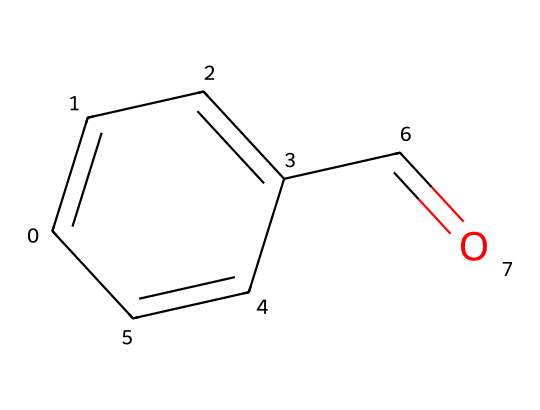What is the molecular formula of benzaldehyde? The molecular formula can be derived from the SMILES representation. In the structure, we have 7 carbon (C) atoms, 6 hydrogen (H) atoms, and 1 oxygen (O) atom, which gives the formula C7H6O.
Answer: C7H6O How many rings are present in benzaldehyde? The SMILES representation shows a cyclic structure with a single six-membered aromatic ring. There are no other rings indicated in the structure.
Answer: 1 What functional group is present in benzaldehyde? The functional group can be identified by looking at the carbonyl (C=O) present in the structure. As it is attached to an aromatic ring, it indicates the presence of an aldehyde.
Answer: aldehyde What is the total number of double bonds in benzaldehyde? By analyzing the SMILES, there are 2 double bonds visible: one in the carbonyl group (C=O) and another in the aromatic ring. Thus, the total number is 2.
Answer: 2 How many hydrogen atoms are adjacent to the carbonyl carbon in benzaldehyde? The carbon atom of the carbonyl group (C=O) is attached to one hydrogen atom in the structure, which makes it an aldehyde. Therefore, the answer is 1.
Answer: 1 What hybridization do the carbon atoms in the carbonyl group exhibit? The carbon atom in the carbonyl group (C=O) has a double bond with oxygen, leading to sp2 hybridization. This is typical for the carbonyl carbon in aldehydes and is evident from its bonding.
Answer: sp2 